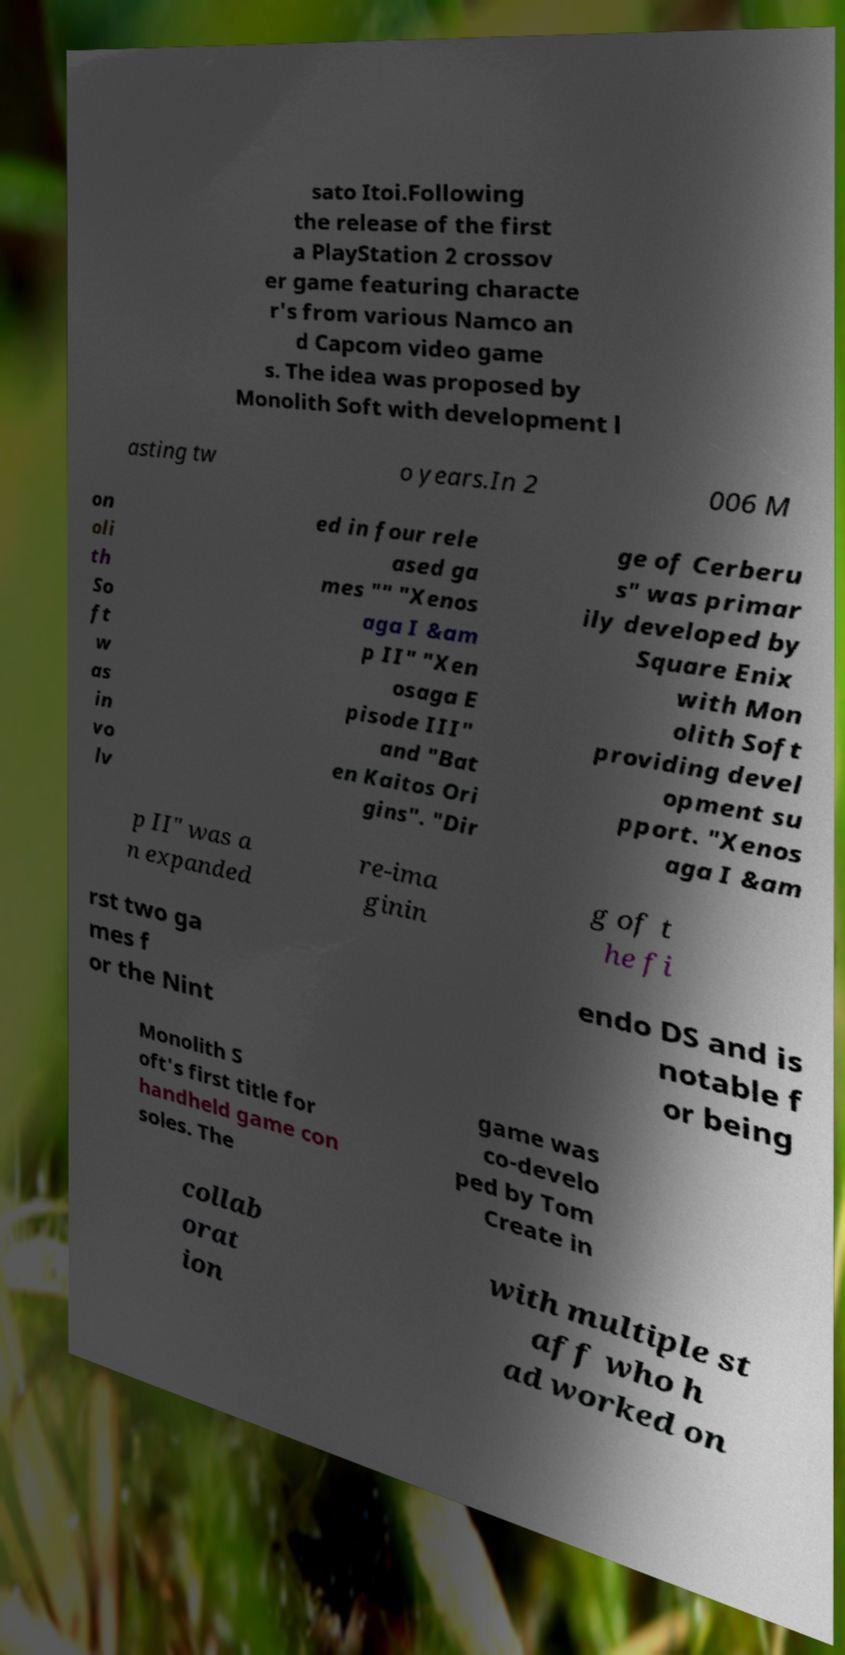Can you read and provide the text displayed in the image?This photo seems to have some interesting text. Can you extract and type it out for me? sato Itoi.Following the release of the first a PlayStation 2 crossov er game featuring characte r's from various Namco an d Capcom video game s. The idea was proposed by Monolith Soft with development l asting tw o years.In 2 006 M on oli th So ft w as in vo lv ed in four rele ased ga mes "" "Xenos aga I &am p II" "Xen osaga E pisode III" and "Bat en Kaitos Ori gins". "Dir ge of Cerberu s" was primar ily developed by Square Enix with Mon olith Soft providing devel opment su pport. "Xenos aga I &am p II" was a n expanded re-ima ginin g of t he fi rst two ga mes f or the Nint endo DS and is notable f or being Monolith S oft's first title for handheld game con soles. The game was co-develo ped by Tom Create in collab orat ion with multiple st aff who h ad worked on 